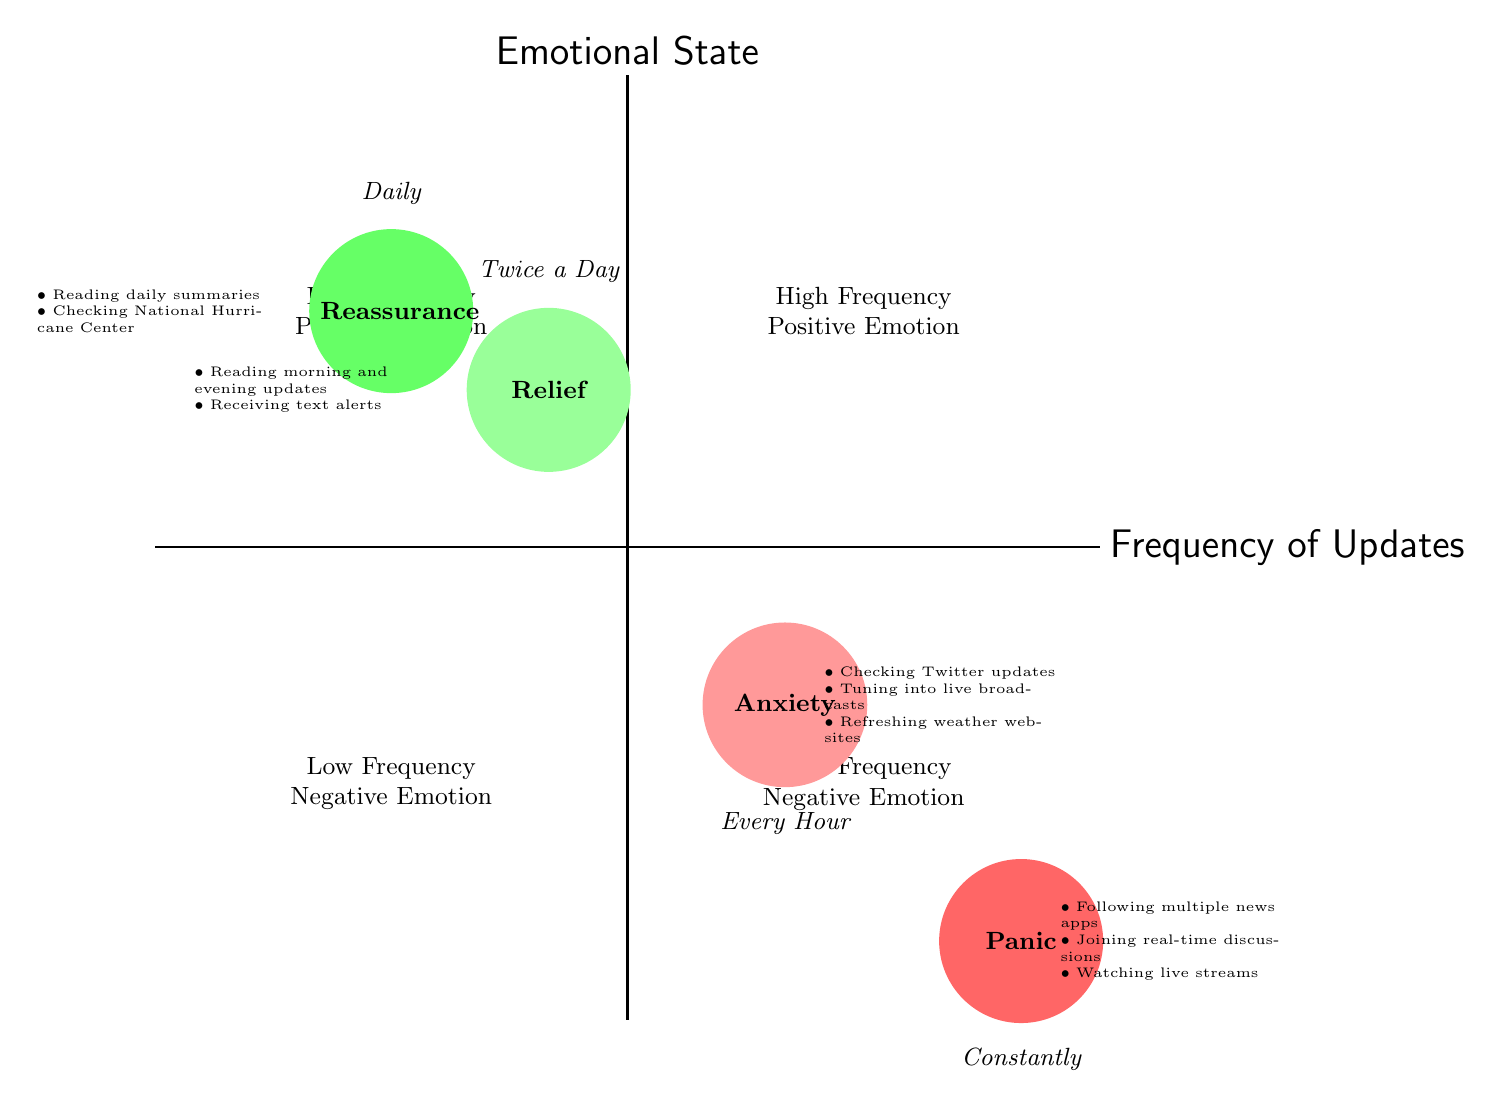What emotional state corresponds to the frequency of updates "Every Hour"? The diagram shows that "Anxiety" is positioned in the quadrant where the frequency of updates is labeled "Every Hour." By looking specifically at the node that represents "Every Hour," we can see the corresponding emotional state clearly indicated.
Answer: Anxiety Which emotional state is associated with the lowest frequency of updates? Based on the quadrant structure, the lowest frequency of updates is "Daily," which corresponds to the emotional state "Reassurance." This can be identified by locating the node in the lower left quadrant and tracing it back to see which emotional state is connected.
Answer: Reassurance How many emotional states are represented in the diagram? The diagram consists of four emotional states: Anxiety, Relief, Panic, and Reassurance. By counting the distinct nodes within the quadrants, we can confirm there are four unique emotional states depicted in the chart.
Answer: Four What is the frequency of updates for the emotional state "Panic"? The "Panic" emotional state appears in the quadrant with a high frequency of updates. The diagram indicates that "Panic" is related to the frequency labeled "Constantly," which is clearly marked in that quadrant.
Answer: Constantly Which emotional states have a high frequency of updates? The high frequency of updates in the diagram is represented by the emotional states "Anxiety" and "Panic." These can be determined by focusing on the upper right and lower right quadrants, which indicate high frequency along with their respective emotional states.
Answer: Anxiety and Panic What examples are provided for the emotional state "Relief"? The examples for "Relief" include reading the morning and evening updates from The Weather Channel and receiving text alerts from the city council. This information can be extracted from the node associated with "Relief" and examining the specific examples listed adjacent to that emotional state.
Answer: Reading the morning and evening updates from The Weather Channel, receiving text alerts from the city council Which frequency of updates is associated with the emotional state "Reassurance"? In the diagram, the emotional state "Reassurance" corresponds to the frequency of updates labeled "Daily." This correlation can be verified by looking at the position of the "Reassurance" node and confirming which frequency it aligns with.
Answer: Daily How do the emotional states differ in terms of positivity? The emotional states "Relief" and "Reassurance" represent positive emotions, while "Anxiety" and "Panic" depict negative emotions. This differentiation is made by analyzing the position of each emotional state within the quadrants and their alignment with positive or negative sentiments denoted in the chart's labeling.
Answer: Relief and Reassurance are positive; Anxiety and Panic are negative 